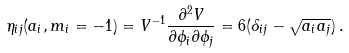Convert formula to latex. <formula><loc_0><loc_0><loc_500><loc_500>\eta _ { i j } ( a _ { i } , m _ { i } = - 1 ) = V ^ { - 1 } \frac { \partial ^ { 2 } V } { \partial \phi _ { i } \partial \phi _ { j } } = 6 ( \delta _ { i j } - \sqrt { a _ { i } a _ { j } } ) \, .</formula> 